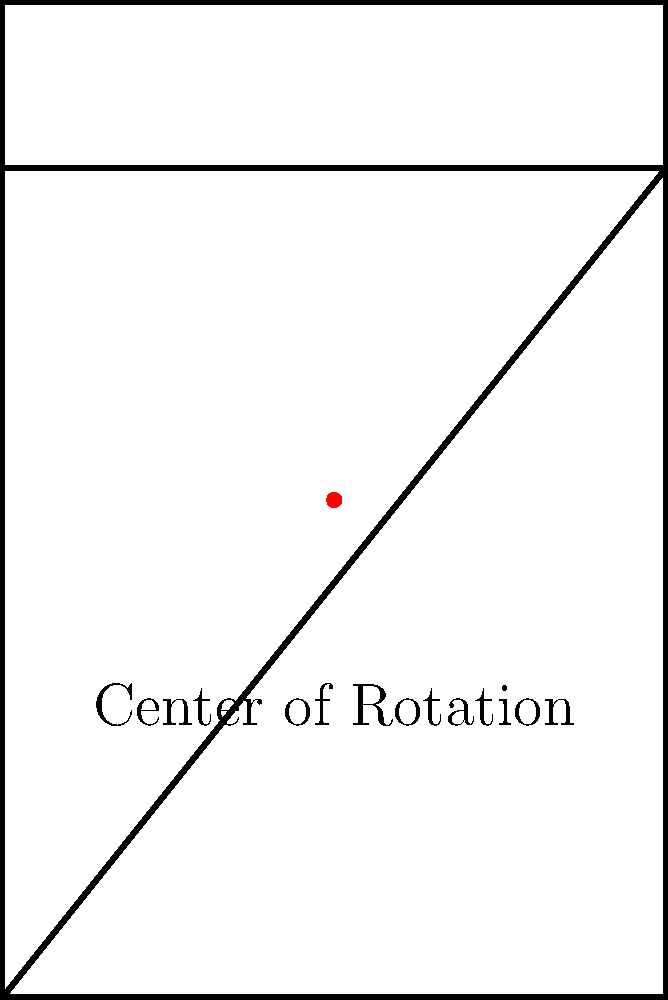Consider the simplified mountain bike frame shown in the diagram. If the frame has rotational symmetry around the center point (marked in red), what is the order of the rotational symmetry group for this frame? To determine the order of the rotational symmetry group, we need to follow these steps:

1. Identify the center of rotation (marked in red on the diagram).

2. Determine how many distinct orientations the frame can have when rotated around this center point while maintaining the same appearance.

3. In this case, we can observe that:
   a) A 180-degree rotation (half turn) brings the frame back to its original appearance.
   b) No other rotation between 0 and 360 degrees (exclusive) results in the same appearance.

4. This means there are only two distinct orientations:
   - The original position (0-degree rotation)
   - The position after a 180-degree rotation

5. In group theory, the number of distinct orientations determines the order of the rotational symmetry group.

Therefore, the order of the rotational symmetry group for this mountain bike frame is 2.
Answer: 2 